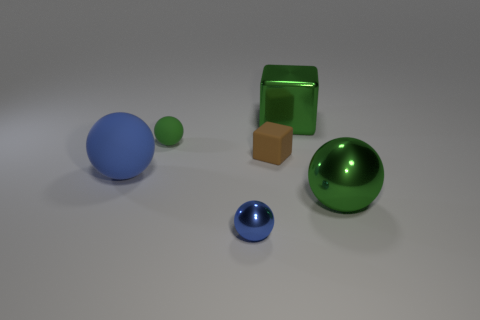Add 2 large blue rubber spheres. How many objects exist? 8 Subtract all blocks. How many objects are left? 4 Add 6 matte objects. How many matte objects exist? 9 Subtract 0 gray spheres. How many objects are left? 6 Subtract all green matte blocks. Subtract all tiny rubber blocks. How many objects are left? 5 Add 3 tiny brown blocks. How many tiny brown blocks are left? 4 